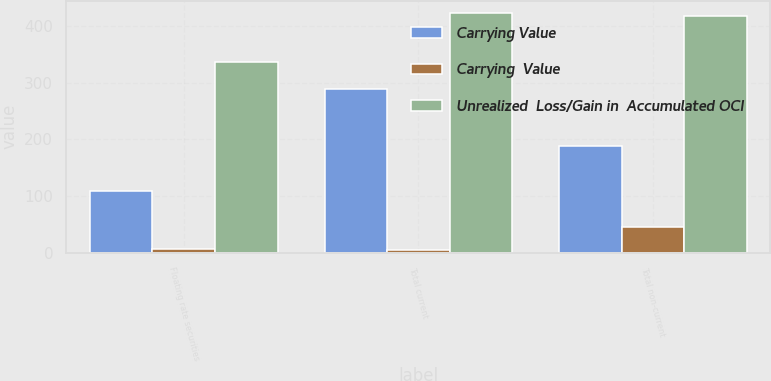<chart> <loc_0><loc_0><loc_500><loc_500><stacked_bar_chart><ecel><fcel>Floating rate securities<fcel>Total current<fcel>Total non-current<nl><fcel>Carrying Value<fcel>109<fcel>289<fcel>188<nl><fcel>Carrying  Value<fcel>6<fcel>5<fcel>45<nl><fcel>Unrealized  Loss/Gain in  Accumulated OCI<fcel>337<fcel>424<fcel>419<nl></chart> 